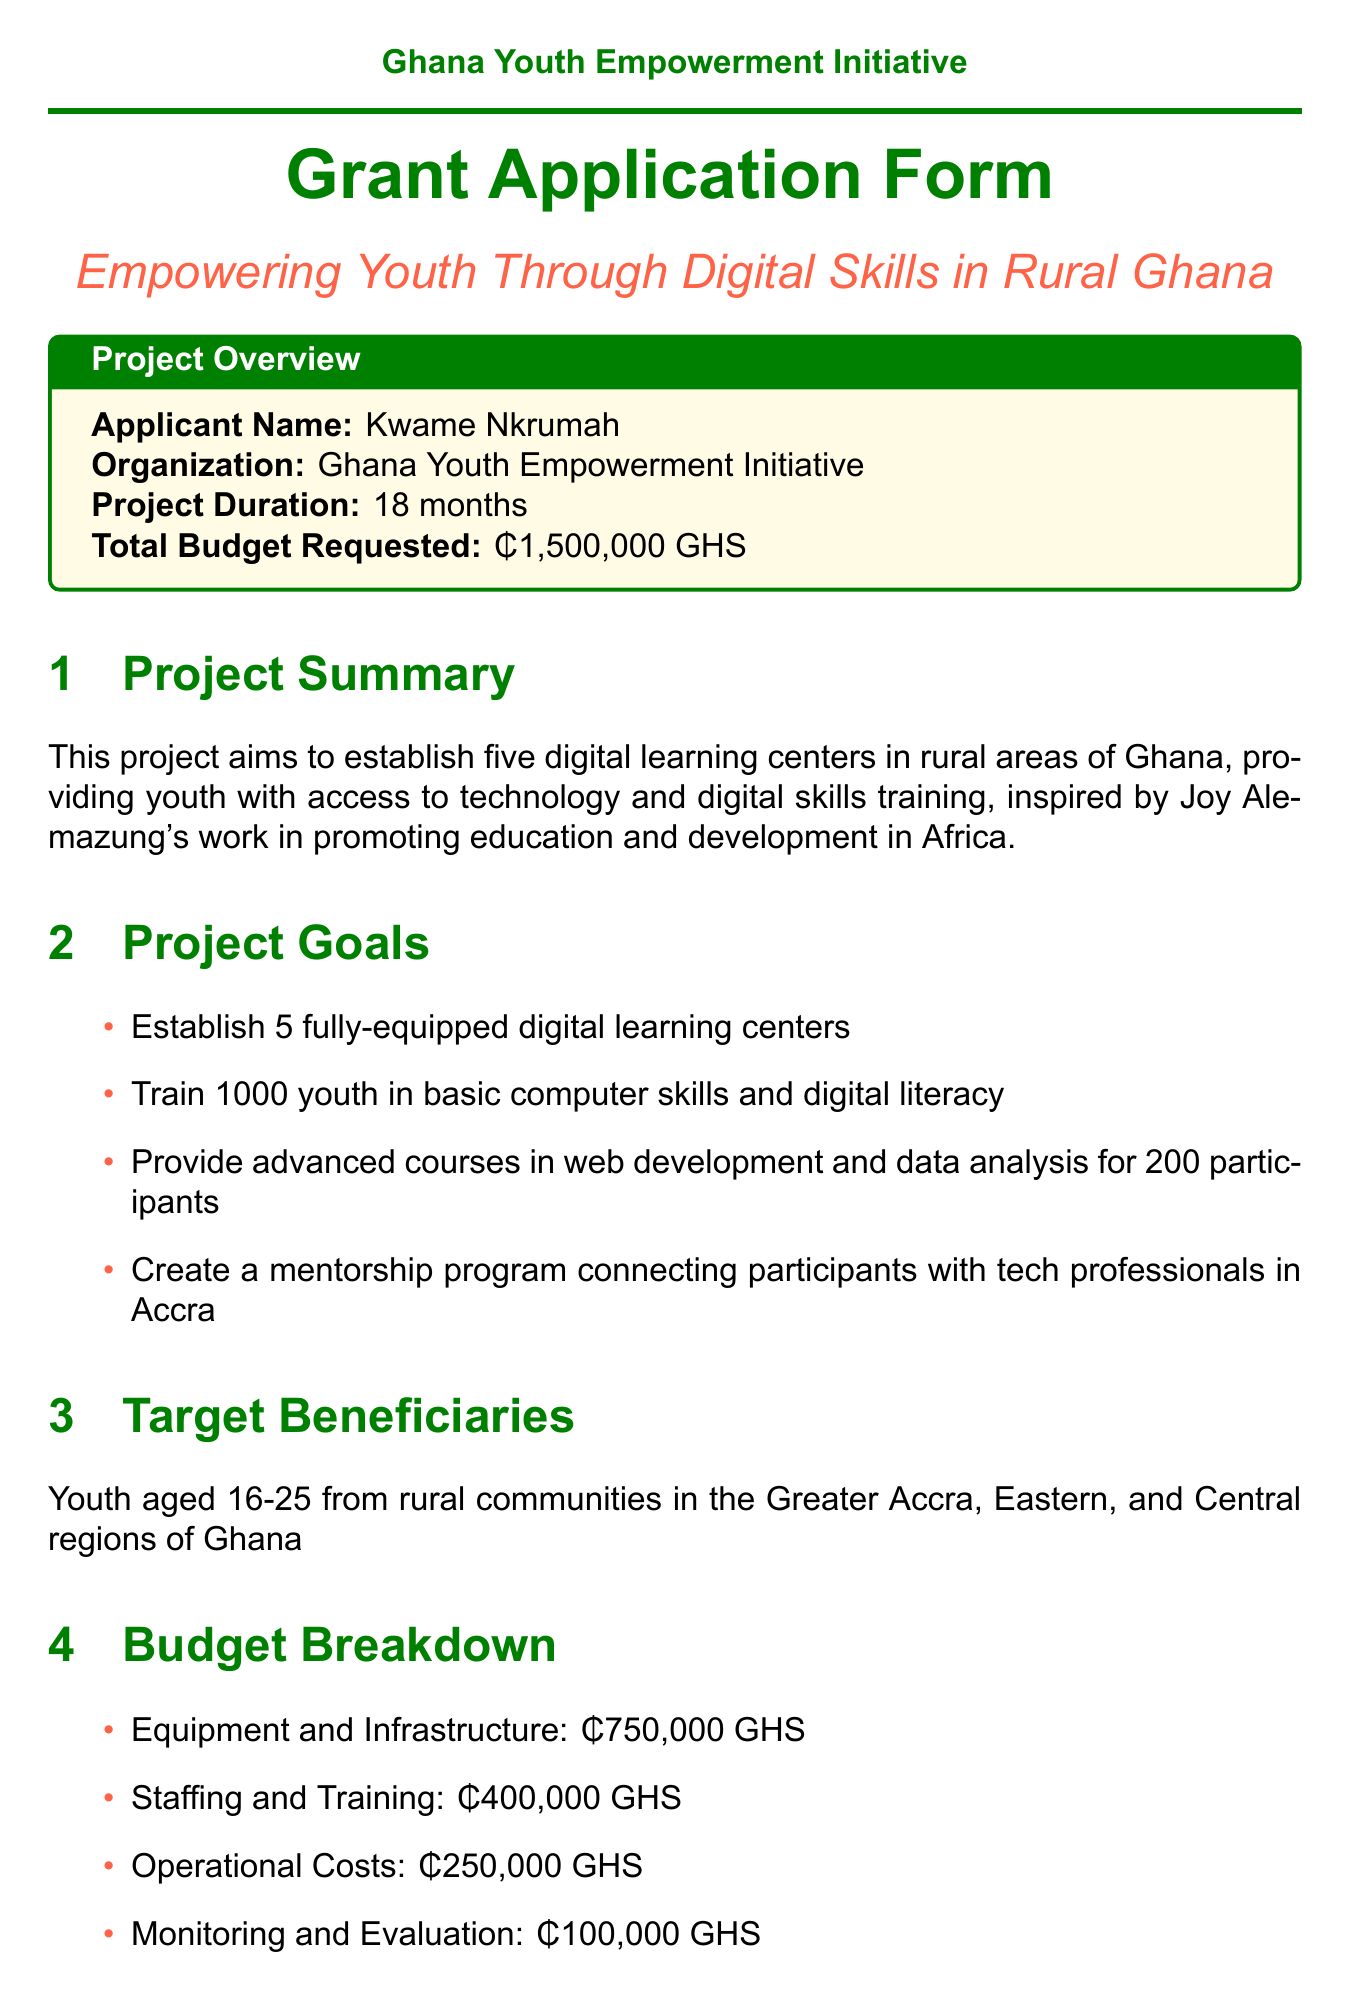What is the project title? The project title is stated at the beginning of the document, focusing on its aim and scope.
Answer: Empowering Youth Through Digital Skills in Rural Ghana Who is the applicant? The applicant's name is provided in a specific section of the document related to the project overview.
Answer: Kwame Nkrumah How much total budget is requested? The total budget requested is clearly defined in the project overview section of the document.
Answer: ₵1,500,000 GHS What is the duration of the project? The duration of the project is mentioned in the project overview section, indicating how long the project will span.
Answer: 18 months What is one of the project goals? One of the goals is listed among several objectives in the project goals section of the document.
Answer: Establish 5 fully-equipped digital learning centers How many youth will be trained? The document specifies a target number of youth to be trained in basic computer skills and digital literacy.
Answer: 1000 What is the budget allocation for Equipment and Infrastructure? The budget breakdown provides specific amounts allocated to various categories, including Equipment and Infrastructure.
Answer: ₵750,000 GHS Which organization is involved in curriculum development? The partner organizations section lists organizations and their roles, including one related to curriculum development.
Answer: Ashesi University What will be conducted in the Monitoring and Evaluation phase? The document outlines specific activities that will take place during each project phase, including this one.
Answer: Conduct mid-term and final evaluations 